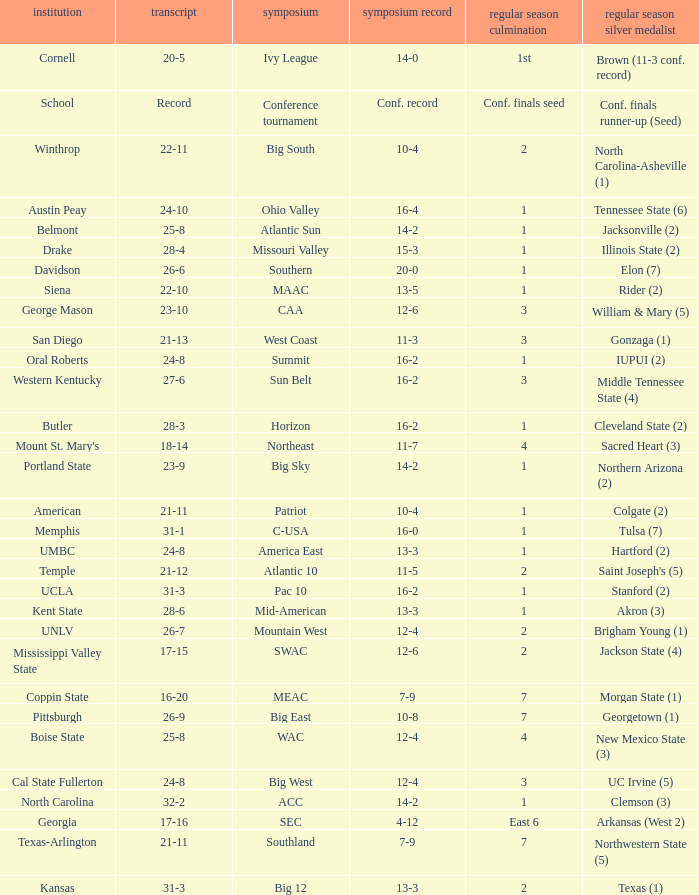For teams in the Sun Belt conference, what is the conference record? 16-2. 